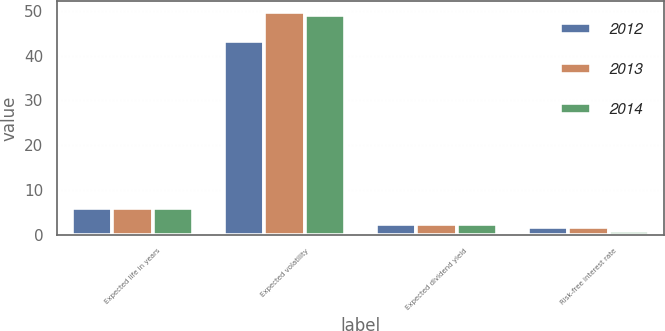<chart> <loc_0><loc_0><loc_500><loc_500><stacked_bar_chart><ecel><fcel>Expected life in years<fcel>Expected volatility<fcel>Expected dividend yield<fcel>Risk-free interest rate<nl><fcel>2012<fcel>6<fcel>43.21<fcel>2.27<fcel>1.74<nl><fcel>2013<fcel>6<fcel>49.63<fcel>2.27<fcel>1.77<nl><fcel>2014<fcel>6<fcel>49.11<fcel>2.39<fcel>0.85<nl></chart> 